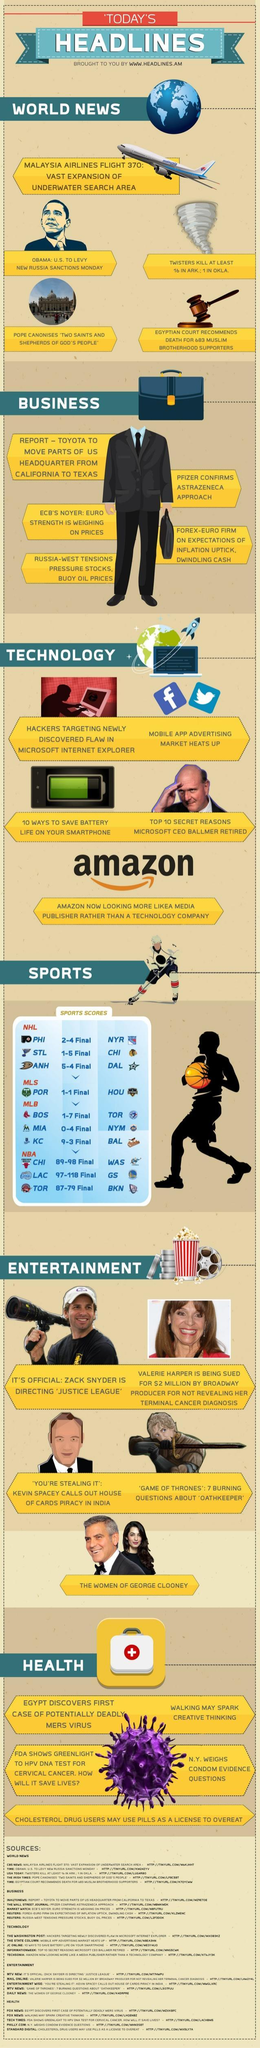who is in the second news given under entertainment?
Answer the question with a short phrase. Valarie Harper who is in the picture given under world news? Obama how many different areas of news given in this infographic? 6 